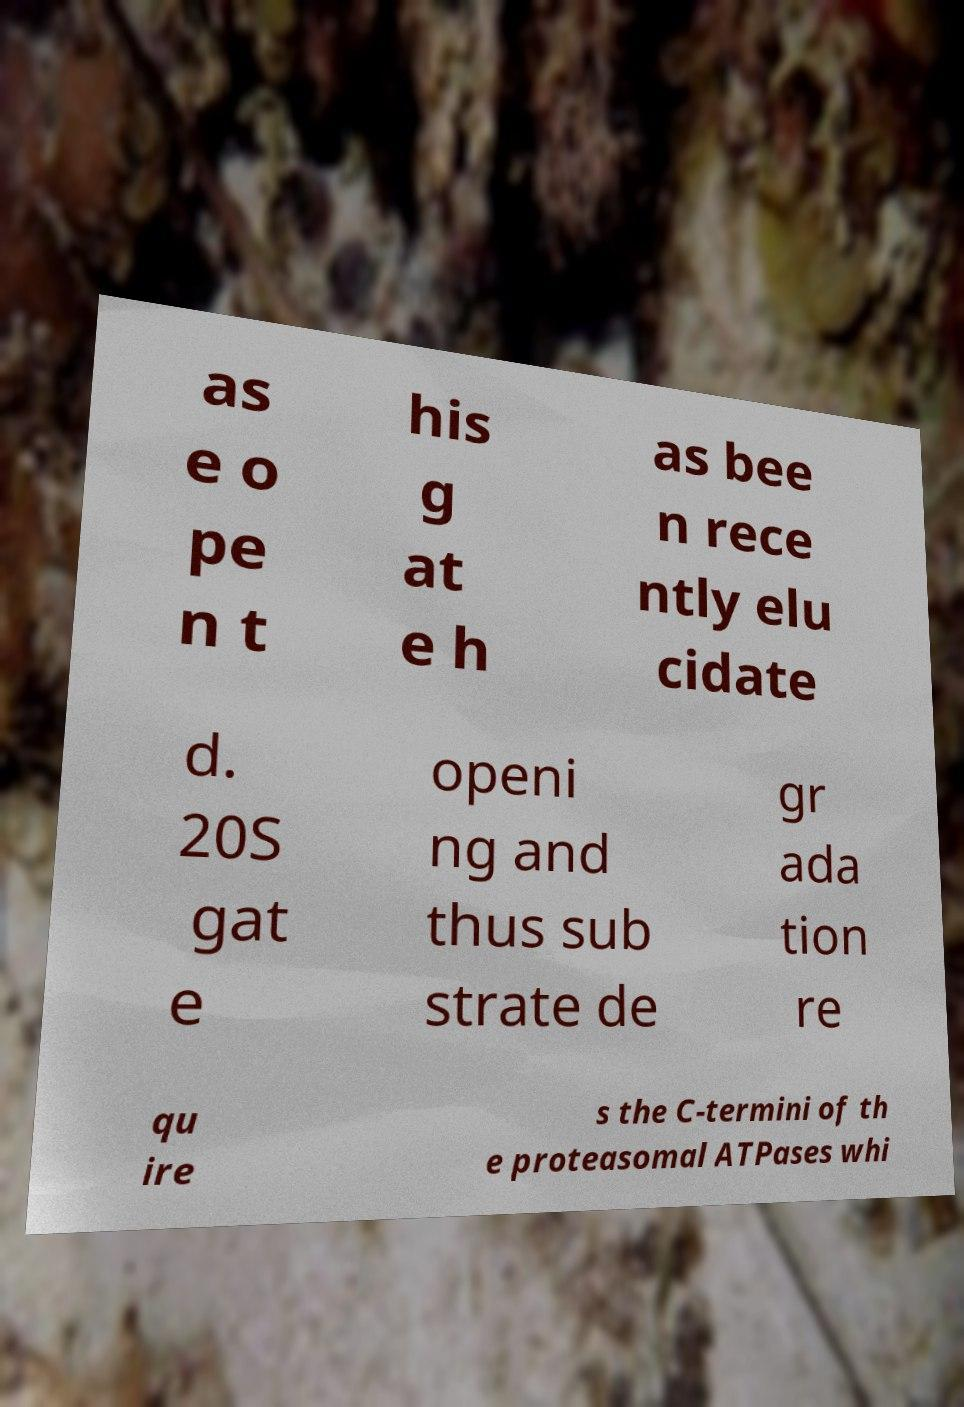Please identify and transcribe the text found in this image. as e o pe n t his g at e h as bee n rece ntly elu cidate d. 20S gat e openi ng and thus sub strate de gr ada tion re qu ire s the C-termini of th e proteasomal ATPases whi 